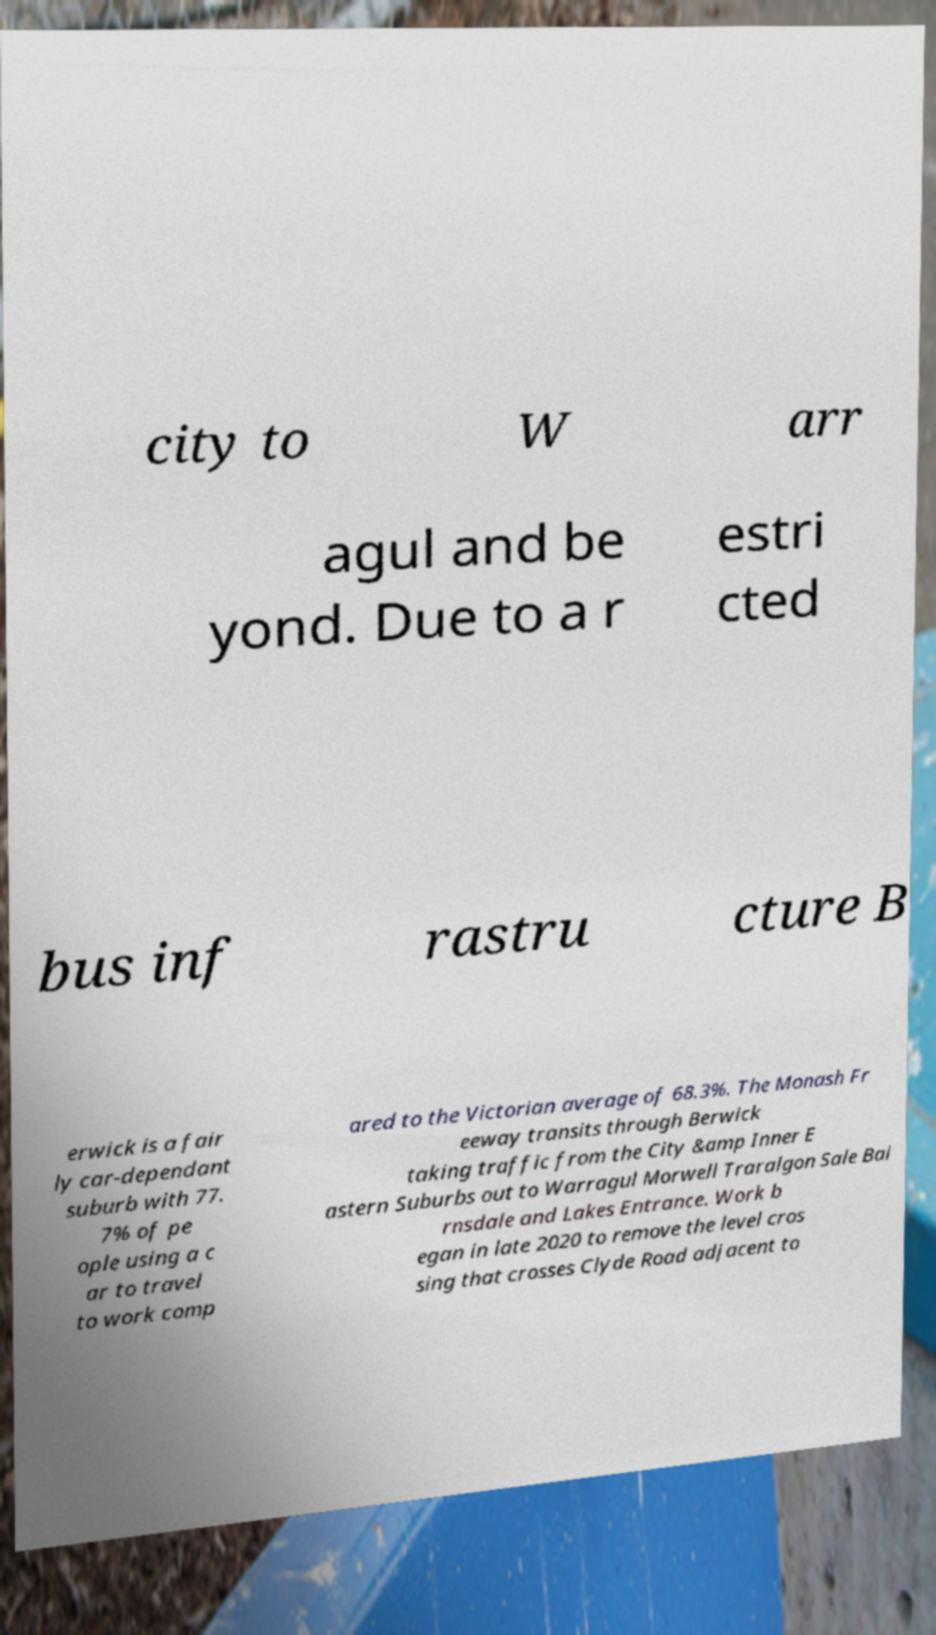What messages or text are displayed in this image? I need them in a readable, typed format. city to W arr agul and be yond. Due to a r estri cted bus inf rastru cture B erwick is a fair ly car-dependant suburb with 77. 7% of pe ople using a c ar to travel to work comp ared to the Victorian average of 68.3%. The Monash Fr eeway transits through Berwick taking traffic from the City &amp Inner E astern Suburbs out to Warragul Morwell Traralgon Sale Bai rnsdale and Lakes Entrance. Work b egan in late 2020 to remove the level cros sing that crosses Clyde Road adjacent to 